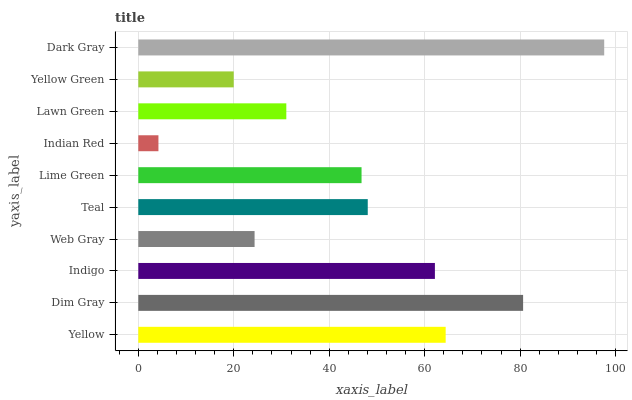Is Indian Red the minimum?
Answer yes or no. Yes. Is Dark Gray the maximum?
Answer yes or no. Yes. Is Dim Gray the minimum?
Answer yes or no. No. Is Dim Gray the maximum?
Answer yes or no. No. Is Dim Gray greater than Yellow?
Answer yes or no. Yes. Is Yellow less than Dim Gray?
Answer yes or no. Yes. Is Yellow greater than Dim Gray?
Answer yes or no. No. Is Dim Gray less than Yellow?
Answer yes or no. No. Is Teal the high median?
Answer yes or no. Yes. Is Lime Green the low median?
Answer yes or no. Yes. Is Lawn Green the high median?
Answer yes or no. No. Is Yellow Green the low median?
Answer yes or no. No. 